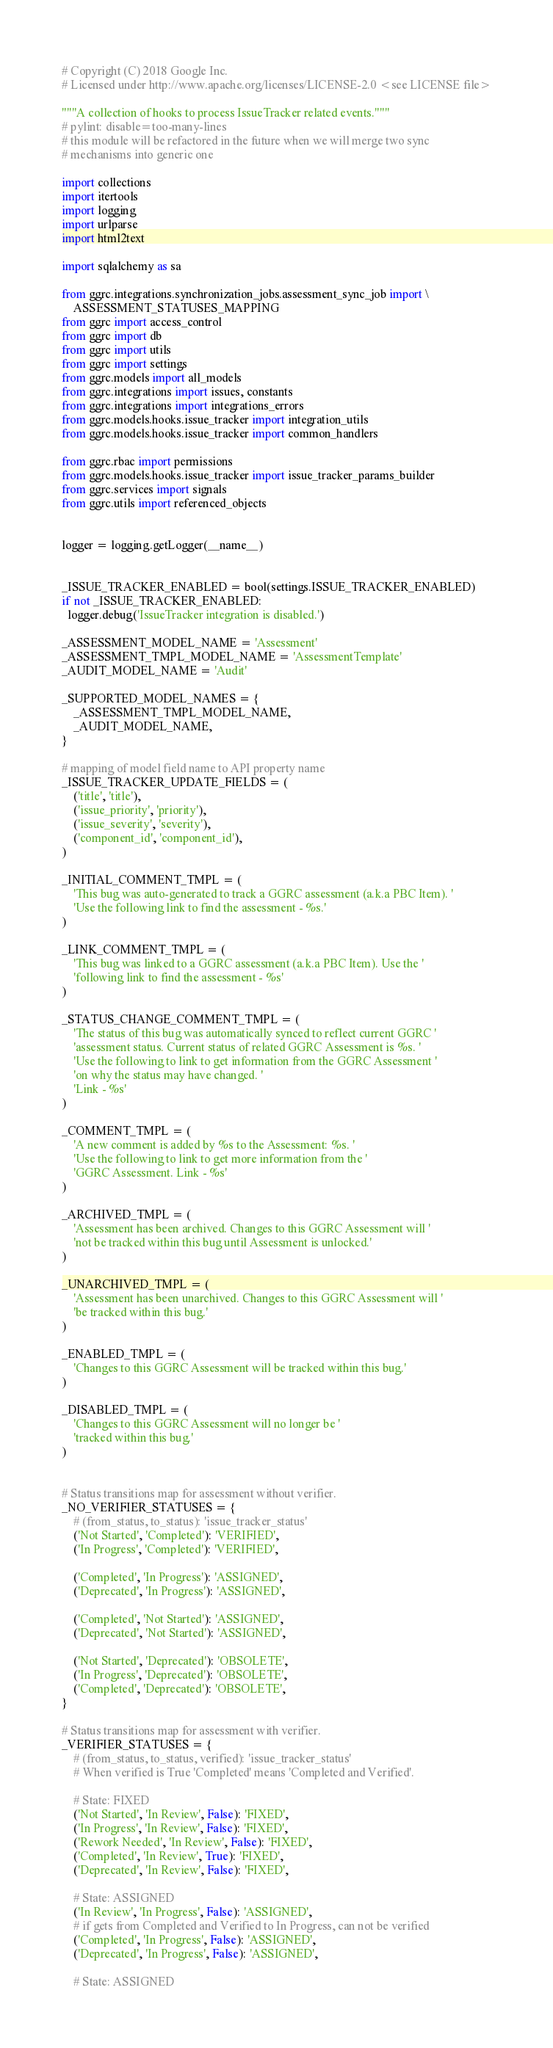Convert code to text. <code><loc_0><loc_0><loc_500><loc_500><_Python_># Copyright (C) 2018 Google Inc.
# Licensed under http://www.apache.org/licenses/LICENSE-2.0 <see LICENSE file>

"""A collection of hooks to process IssueTracker related events."""
# pylint: disable=too-many-lines
# this module will be refactored in the future when we will merge two sync
# mechanisms into generic one

import collections
import itertools
import logging
import urlparse
import html2text

import sqlalchemy as sa

from ggrc.integrations.synchronization_jobs.assessment_sync_job import \
    ASSESSMENT_STATUSES_MAPPING
from ggrc import access_control
from ggrc import db
from ggrc import utils
from ggrc import settings
from ggrc.models import all_models
from ggrc.integrations import issues, constants
from ggrc.integrations import integrations_errors
from ggrc.models.hooks.issue_tracker import integration_utils
from ggrc.models.hooks.issue_tracker import common_handlers

from ggrc.rbac import permissions
from ggrc.models.hooks.issue_tracker import issue_tracker_params_builder
from ggrc.services import signals
from ggrc.utils import referenced_objects


logger = logging.getLogger(__name__)


_ISSUE_TRACKER_ENABLED = bool(settings.ISSUE_TRACKER_ENABLED)
if not _ISSUE_TRACKER_ENABLED:
  logger.debug('IssueTracker integration is disabled.')

_ASSESSMENT_MODEL_NAME = 'Assessment'
_ASSESSMENT_TMPL_MODEL_NAME = 'AssessmentTemplate'
_AUDIT_MODEL_NAME = 'Audit'

_SUPPORTED_MODEL_NAMES = {
    _ASSESSMENT_TMPL_MODEL_NAME,
    _AUDIT_MODEL_NAME,
}

# mapping of model field name to API property name
_ISSUE_TRACKER_UPDATE_FIELDS = (
    ('title', 'title'),
    ('issue_priority', 'priority'),
    ('issue_severity', 'severity'),
    ('component_id', 'component_id'),
)

_INITIAL_COMMENT_TMPL = (
    'This bug was auto-generated to track a GGRC assessment (a.k.a PBC Item). '
    'Use the following link to find the assessment - %s.'
)

_LINK_COMMENT_TMPL = (
    'This bug was linked to a GGRC assessment (a.k.a PBC Item). Use the '
    'following link to find the assessment - %s'
)

_STATUS_CHANGE_COMMENT_TMPL = (
    'The status of this bug was automatically synced to reflect current GGRC '
    'assessment status. Current status of related GGRC Assessment is %s. '
    'Use the following to link to get information from the GGRC Assessment '
    'on why the status may have changed. '
    'Link - %s'
)

_COMMENT_TMPL = (
    'A new comment is added by %s to the Assessment: %s. '
    'Use the following to link to get more information from the '
    'GGRC Assessment. Link - %s'
)

_ARCHIVED_TMPL = (
    'Assessment has been archived. Changes to this GGRC Assessment will '
    'not be tracked within this bug until Assessment is unlocked.'
)

_UNARCHIVED_TMPL = (
    'Assessment has been unarchived. Changes to this GGRC Assessment will '
    'be tracked within this bug.'
)

_ENABLED_TMPL = (
    'Changes to this GGRC Assessment will be tracked within this bug.'
)

_DISABLED_TMPL = (
    'Changes to this GGRC Assessment will no longer be '
    'tracked within this bug.'
)


# Status transitions map for assessment without verifier.
_NO_VERIFIER_STATUSES = {
    # (from_status, to_status): 'issue_tracker_status'
    ('Not Started', 'Completed'): 'VERIFIED',
    ('In Progress', 'Completed'): 'VERIFIED',

    ('Completed', 'In Progress'): 'ASSIGNED',
    ('Deprecated', 'In Progress'): 'ASSIGNED',

    ('Completed', 'Not Started'): 'ASSIGNED',
    ('Deprecated', 'Not Started'): 'ASSIGNED',

    ('Not Started', 'Deprecated'): 'OBSOLETE',
    ('In Progress', 'Deprecated'): 'OBSOLETE',
    ('Completed', 'Deprecated'): 'OBSOLETE',
}

# Status transitions map for assessment with verifier.
_VERIFIER_STATUSES = {
    # (from_status, to_status, verified): 'issue_tracker_status'
    # When verified is True 'Completed' means 'Completed and Verified'.

    # State: FIXED
    ('Not Started', 'In Review', False): 'FIXED',
    ('In Progress', 'In Review', False): 'FIXED',
    ('Rework Needed', 'In Review', False): 'FIXED',
    ('Completed', 'In Review', True): 'FIXED',
    ('Deprecated', 'In Review', False): 'FIXED',

    # State: ASSIGNED
    ('In Review', 'In Progress', False): 'ASSIGNED',
    # if gets from Completed and Verified to In Progress, can not be verified
    ('Completed', 'In Progress', False): 'ASSIGNED',
    ('Deprecated', 'In Progress', False): 'ASSIGNED',

    # State: ASSIGNED</code> 